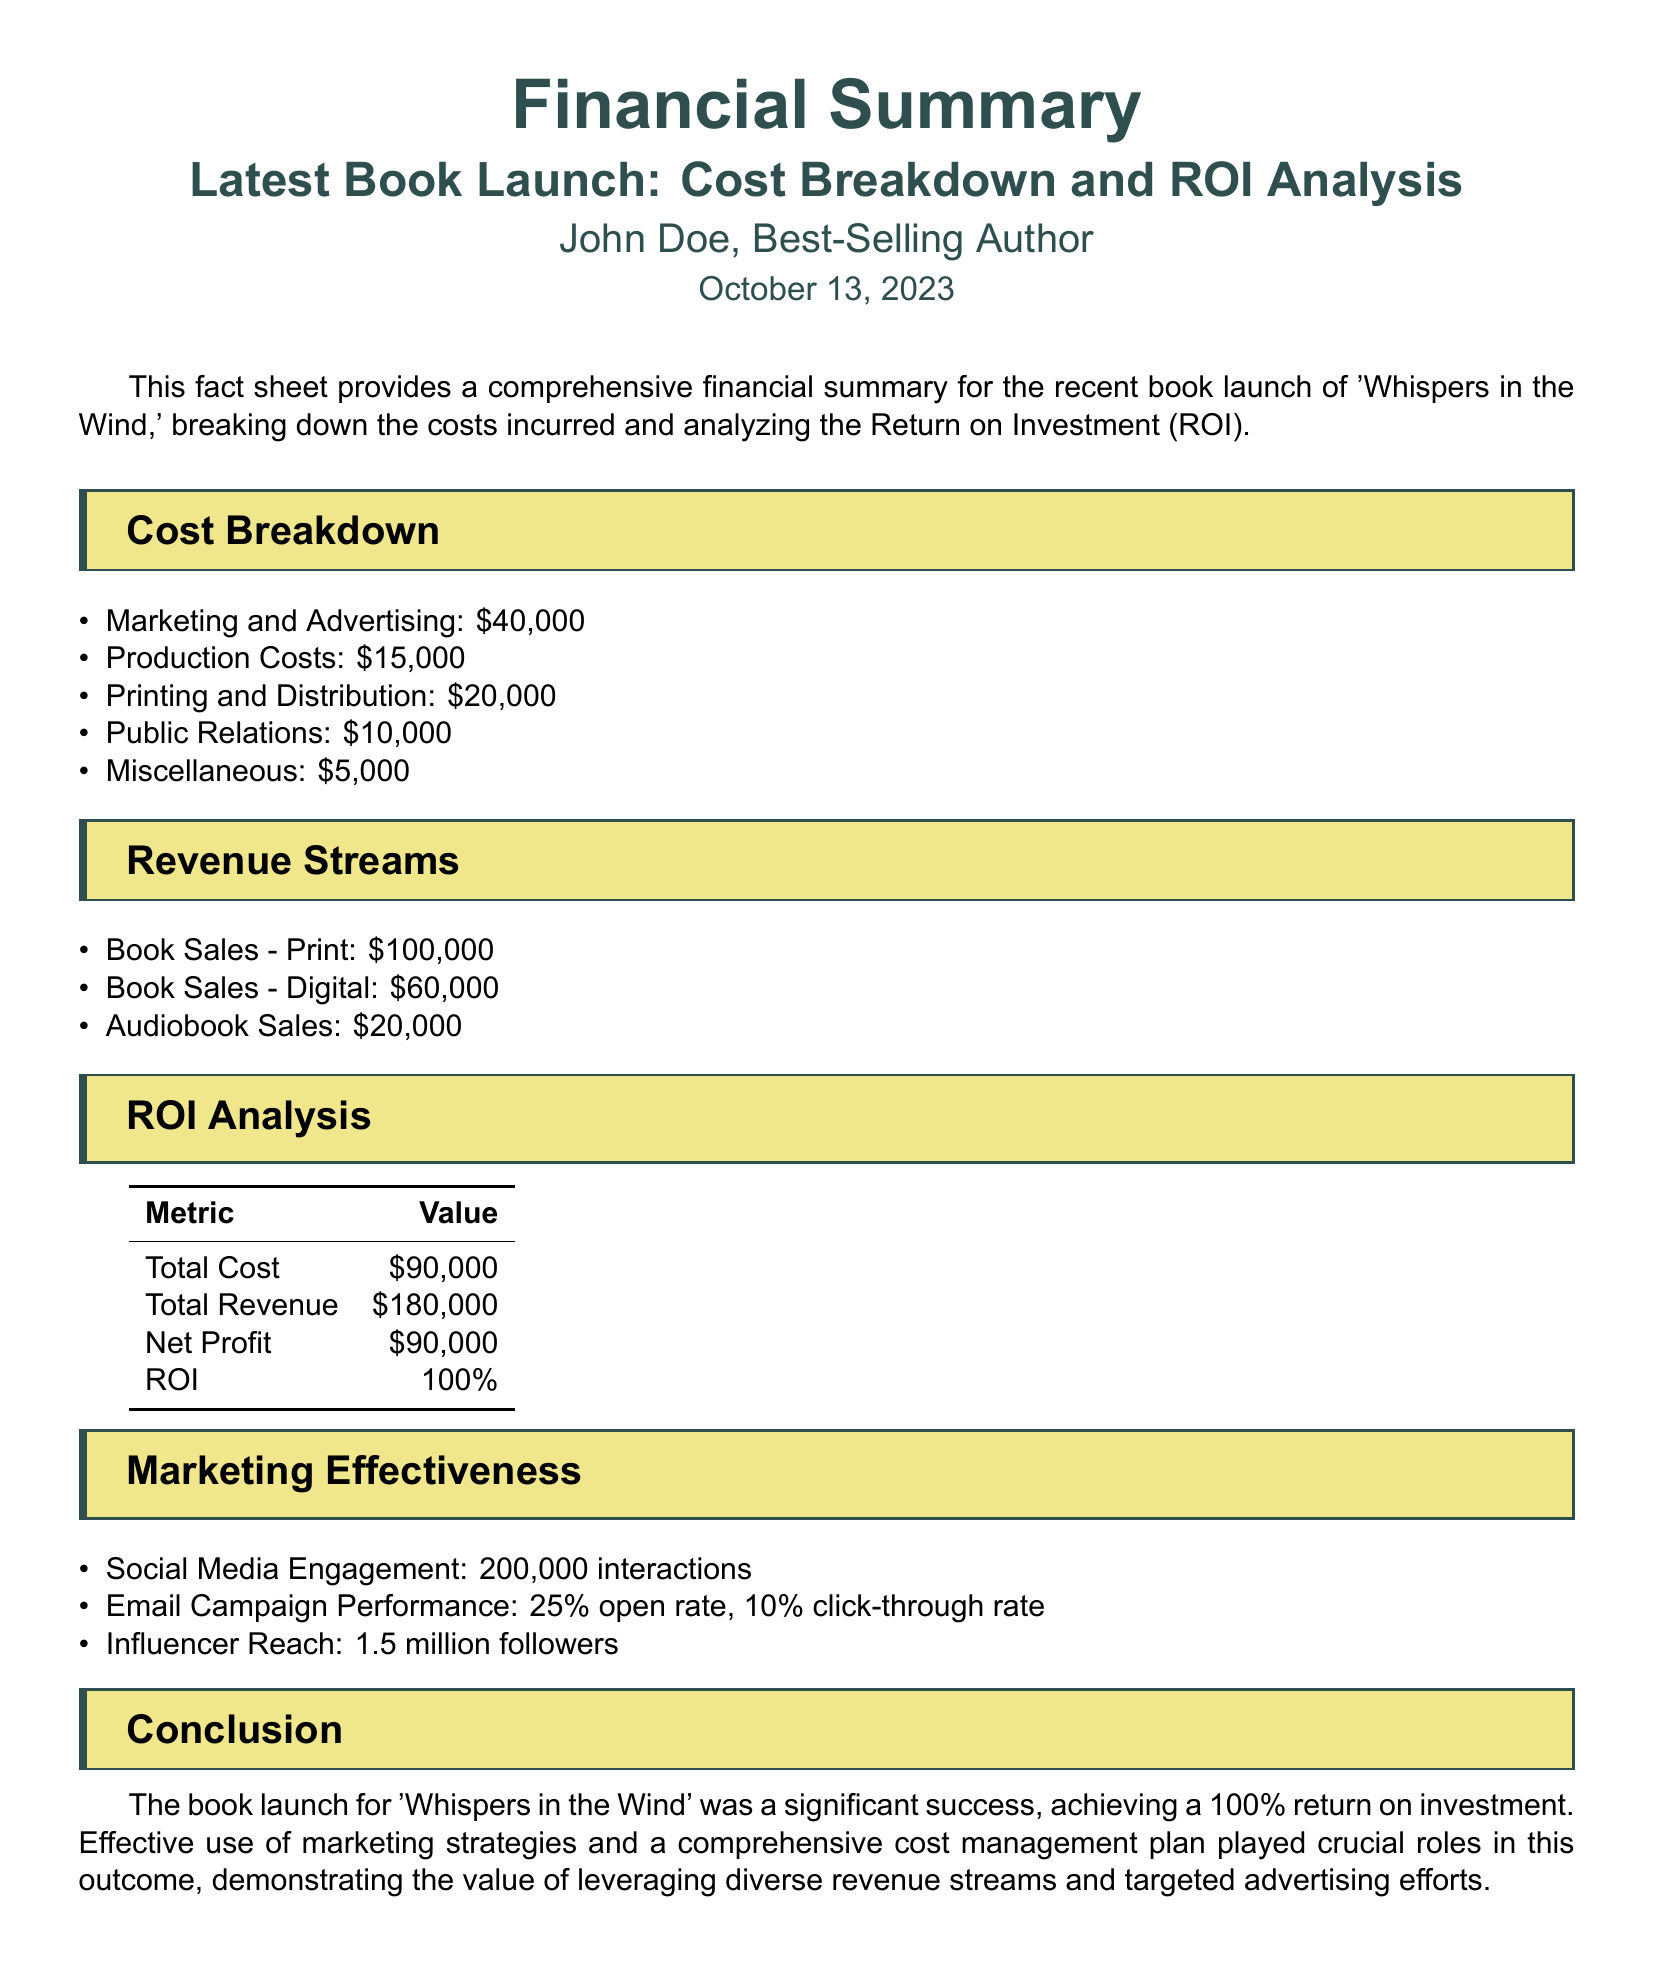what is the total cost? The total cost is provided in the ROI analysis section, which adds up all incurred costs.
Answer: $90,000 what is the total revenue from digital book sales? The digital book sales revenue is listed under revenue streams, specifically mentioning the amount for digital sales.
Answer: $60,000 what is the net profit from the book launch? The net profit is calculated through the total revenue minus the total cost, which is defined in the ROI analysis section.
Answer: $90,000 what was the marketing and advertising cost? The cost for marketing and advertising is explicitly stated in the cost breakdown section.
Answer: $40,000 what is the ROI percentage? The ROI is directly stated in the ROI analysis table, showing the percentage return on investment.
Answer: 100% how many interactions did social media engagement reach? The specific number of interactions from social media is provided in the marketing effectiveness section.
Answer: 200,000 interactions what was the total revenue? The total revenue is the sum of all revenue sources and is mentioned in the ROI analysis.
Answer: $180,000 what is the open rate of the email campaign? The open rate of the email campaign is mentioned in the marketing effectiveness section.
Answer: 25% what is the production cost? The production cost is listed in the cost breakdown section.
Answer: $15,000 who is the author of the document? The author of the fact sheet is stated at the beginning of the document.
Answer: John Doe 